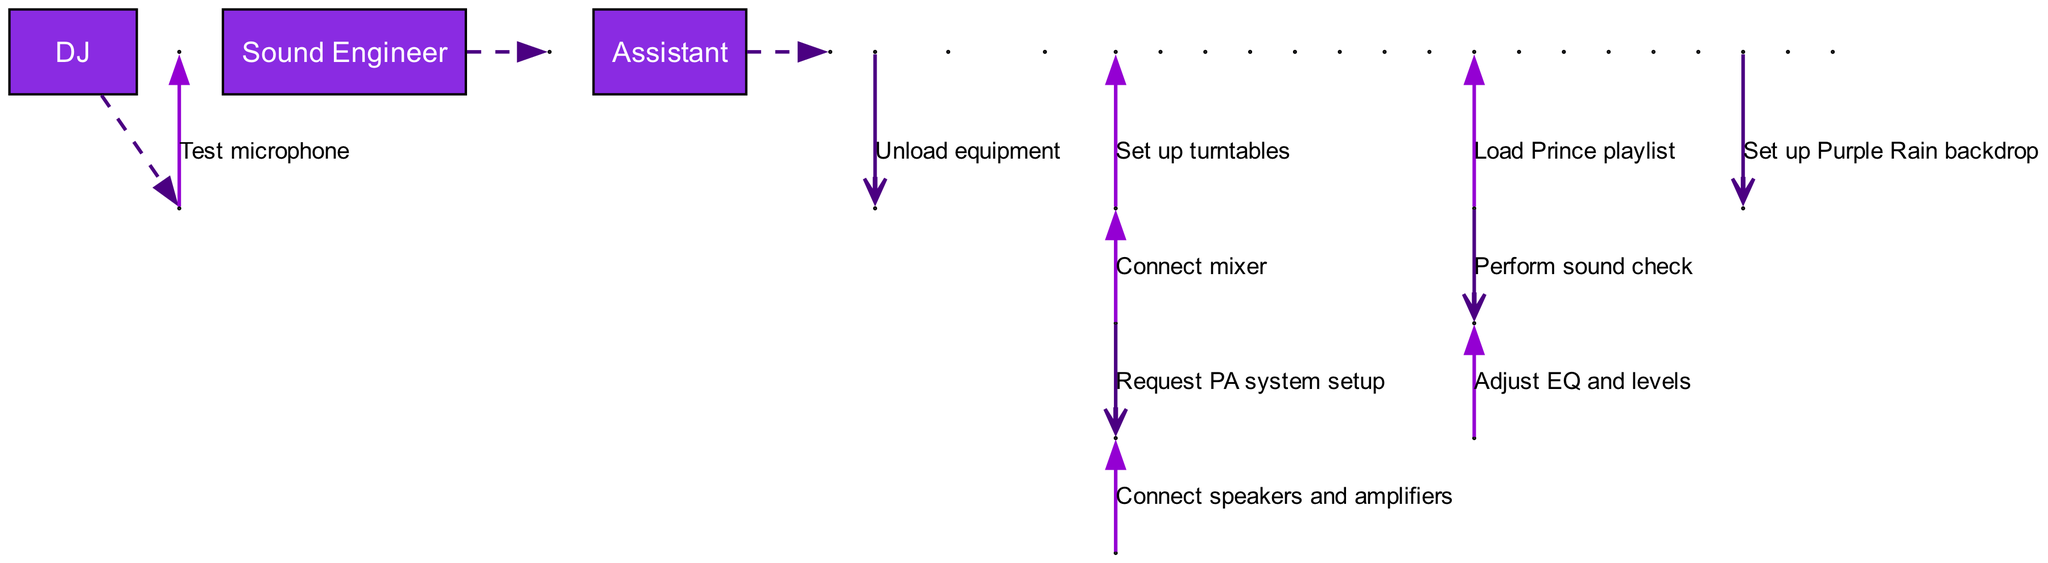What is the first action in the sequence? The first action in the sequence is "Unload equipment," which is initiated by the DJ. This is the first entry in the list of actions.
Answer: Unload equipment Who is responsible for connecting the speakers and amplifiers? The action to connect speakers and amplifiers is performed by the Sound Engineer, as indicated in the sequence where the Sound Engineer takes this action following the request from the DJ.
Answer: Sound Engineer How many actors are involved in the sequence? There are three actors involved in the sequence: DJ, Sound Engineer, and Assistant. This can be determined by counting the entries in the actors' list.
Answer: 3 What action occurs right after setting up turntables? Following the action of setting up turntables, the next action is "Connect mixer." This is determined by examining the order of actions in the sequence.
Answer: Connect mixer Which actor performs the sound check? The DJ is the one who performs the action of "Perform sound check," which is directed towards the Sound Engineer, indicating their collaboration during this step.
Answer: DJ What is the last action in the sequence? The last action in the sequence is "Test microphone." This is found at the end of the ordered list of actions.
Answer: Test microphone Which action requires assistance from the Sound Engineer? The action "Perform sound check" requires assistance from the Sound Engineer, as it is initiated by the DJ and directly involves the Sound Engineer's expertise.
Answer: Perform sound check How many actions does the DJ perform on their own? The DJ performs a total of five actions on their own: "Set up turntables," "Connect mixer," "Load Prince playlist," "Set up Purple Rain backdrop," and "Test microphone." These actions do not involve any other actor.
Answer: 5 What does the DJ set up as a backdrop for the gathering? The DJ sets up a "Purple Rain backdrop" for the gathering, which is explicitly mentioned as one of the actions performed by the DJ in the sequence.
Answer: Purple Rain backdrop 